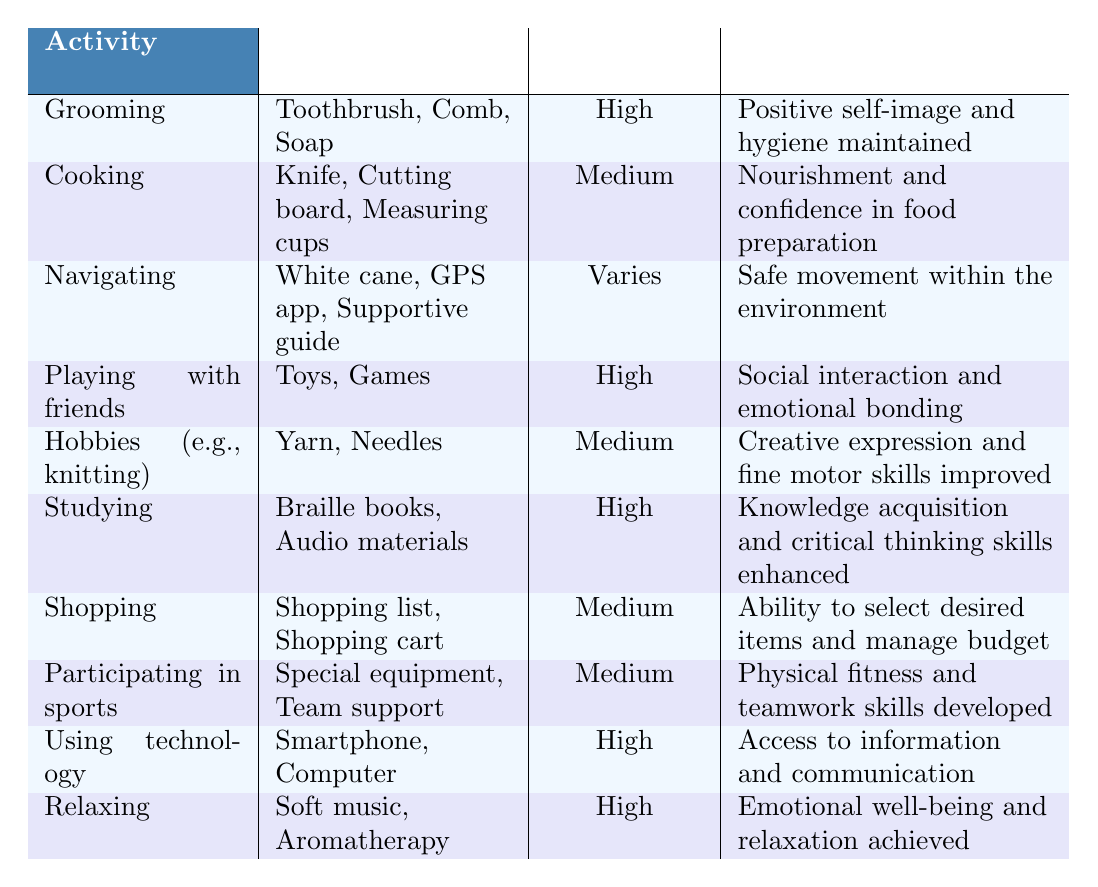What activity has the highest independence level? Looking at the table, the activities with a "High" independence level are Grooming, Playing with friends, Studying, Using technology, and Relaxing. Therefore, there isn't just one activity; multiple activities share this highest independence level.
Answer: Multiple activities What tools are used for cooking? The table indicates that the tools used for cooking are Knife, Cutting board, and Measuring cups.
Answer: Knife, Cutting board, Measuring cups Is shopping considered a high independence activity? According to the table, shopping has a "Medium" independence level. Therefore, shopping is not considered a high independence activity.
Answer: No Which two activities have the same independence level? By examining the independence levels, Cooking, Hobbies (e.g., knitting), Shopping, and Participating in sports all share a "Medium" independence level. Therefore, Cooking and Hobbies both share this level.
Answer: Cooking and Hobbies (e.g., knitting) What is the outcome of studying? The table specifies that the outcome of studying is knowledge acquisition and critical thinking skills enhanced.
Answer: Knowledge acquisition and critical thinking skills enhanced How many activities have a positive outcome? All activities listed in the table have a positive outcome. Counting them, we find there are ten activities in total.
Answer: Ten activities Which activity utilizes a smartphone? Upon reviewing the table, the activity that utilizes a smartphone is Using technology.
Answer: Using technology What are the outcomes for activities with a high independence level? The activities with a high independence level are Grooming, Playing with friends, Studying, Using technology, and Relaxing. Their respective outcomes are positive self-image and hygiene maintained, social interaction and emotional bonding, knowledge acquisition and critical thinking skills enhanced, access to information and communication, and emotional well-being and relaxation achieved.
Answer: Various positive outcomes What is the relationship between independence level and social interaction? The table shows that Playing with friends has a high independence level and results in social interaction and emotional bonding. Therefore, there is a direct relationship where a high independence level in this context supports social interaction.
Answer: Direct relationship 